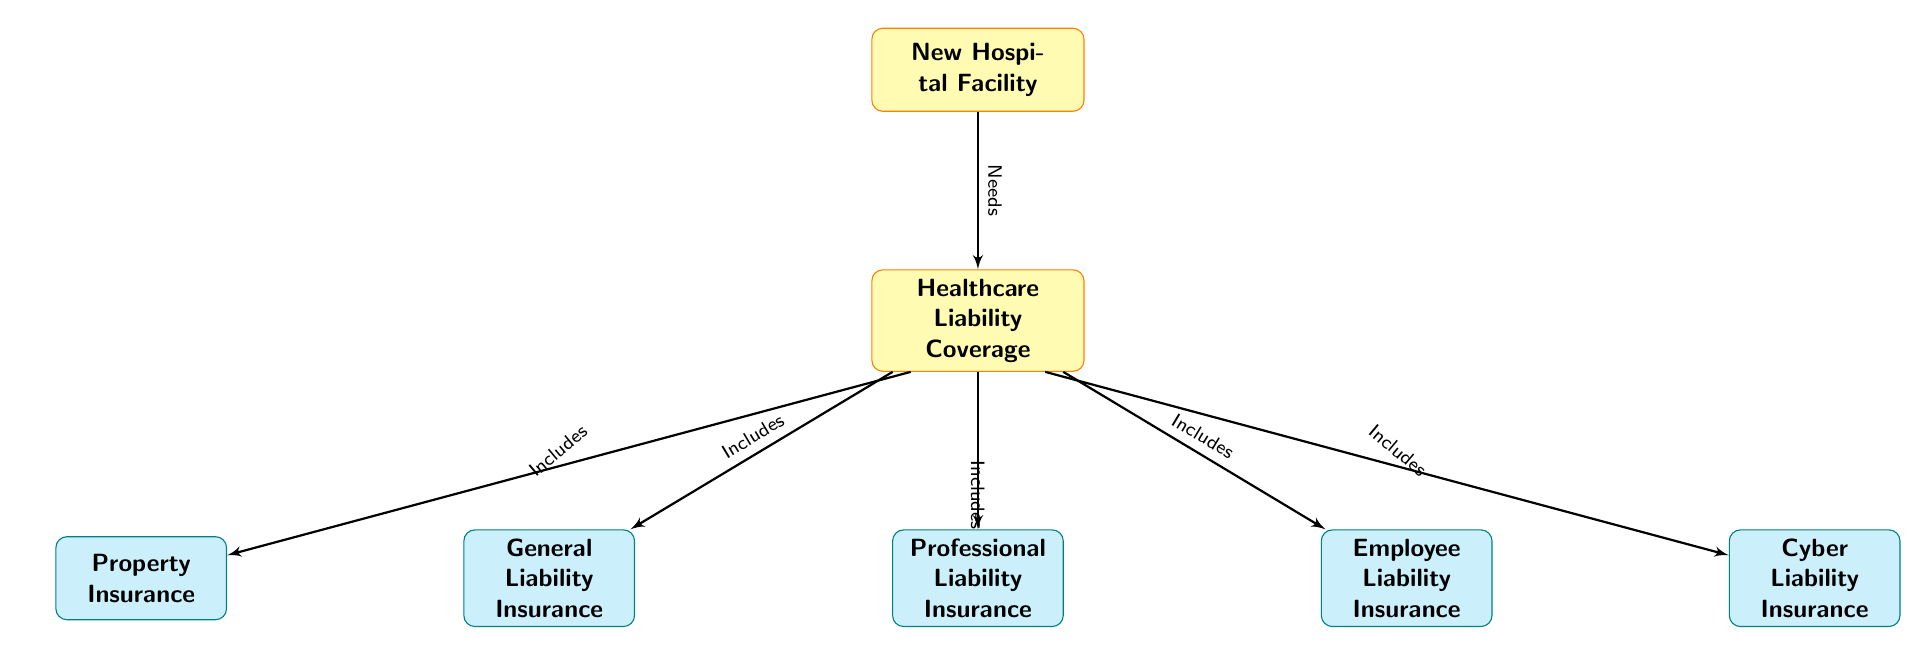what is the main topic of the diagram? The main topic is represented at the top of the diagram, which is labeled "New Hospital Facility." This indicates the primary focus of the diagram is related to a new hospital.
Answer: New Hospital Facility how many subcategories of healthcare liability coverage are presented? The diagram lists three main categories of healthcare liability coverage connected to the main box labeled "Healthcare Liability Coverage." These are "General Liability Insurance," "Professional Liability Insurance," and "Employee Liability Insurance." Counting these gives a total of three subcategories.
Answer: 3 what type of insurance includes property insurance? The diagram shows that "Property Insurance" is connected to "Healthcare Liability Coverage" through an edge labeled "Includes." This indicates that at least "Property Insurance" is a part of the broader category of liability coverage.
Answer: Healthcare Liability Coverage which insurance is shown adjacent to employee liability insurance? The diagram illustrates that "Cyber Liability Insurance" is located to the right of "Employee Liability Insurance," indicating a close relationship or categorization next to it.
Answer: Cyber Liability Insurance what is the relationship between "New Hospital Facility" and "Healthcare Liability Coverage"? The arrow labeled "Needs" connects "New Hospital Facility" to "Healthcare Liability Coverage," indicating that the new facility requires or necessitates the liability coverage.
Answer: Needs what additional type of liability insurance is mentioned that is not directly related to patient care? The diagram includes "Cyber Liability Insurance" as one of the types of liability coverage. This is an additional insurance type that does not directly relate to healthcare but is increasingly important due to digital vulnerabilities.
Answer: Cyber Liability Insurance which subcategory is positioned below general liability insurance? The diagram indicates that "Professional Liability Insurance" is located directly below "General Liability Insurance," suggesting a hierarchical or categorical arrangement of these types of insurance coverage.
Answer: Professional Liability Insurance what insurance type has no direct left or right neighbor? In the diagram, "Professional Liability Insurance" is positioned centrally and does not have any neighboring insurance types to the left or right, distinguishing it from the others that are more closely clustered.
Answer: Professional Liability Insurance 